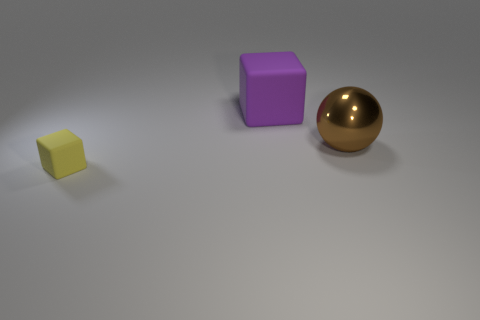Subtract all yellow cubes. How many cubes are left? 1 Add 1 big brown balls. How many objects exist? 4 Subtract 1 blocks. How many blocks are left? 1 Subtract 0 cyan balls. How many objects are left? 3 Subtract all balls. How many objects are left? 2 Subtract all green spheres. Subtract all purple blocks. How many spheres are left? 1 Subtract all gray balls. How many red blocks are left? 0 Subtract all yellow things. Subtract all small things. How many objects are left? 1 Add 3 shiny spheres. How many shiny spheres are left? 4 Add 3 large brown spheres. How many large brown spheres exist? 4 